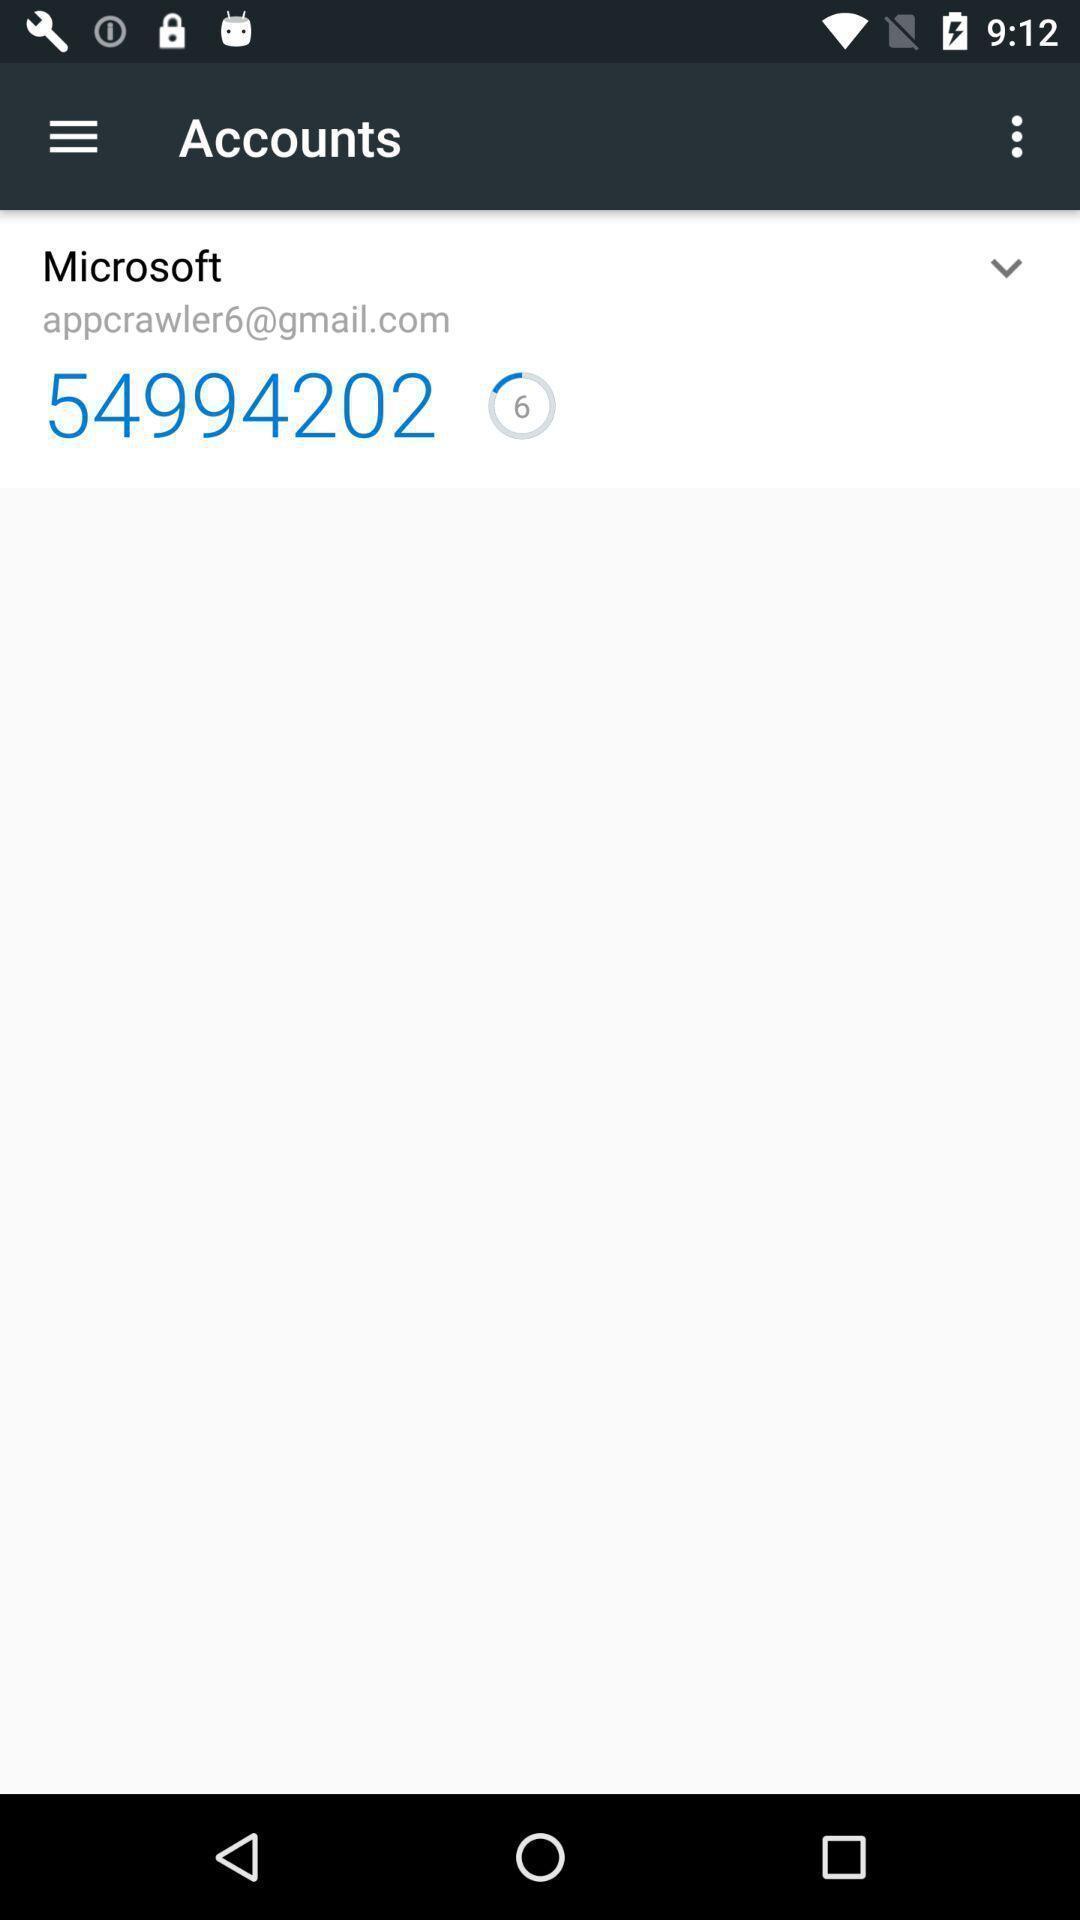Please provide a description for this image. Screen shows accounts of a mail app. 